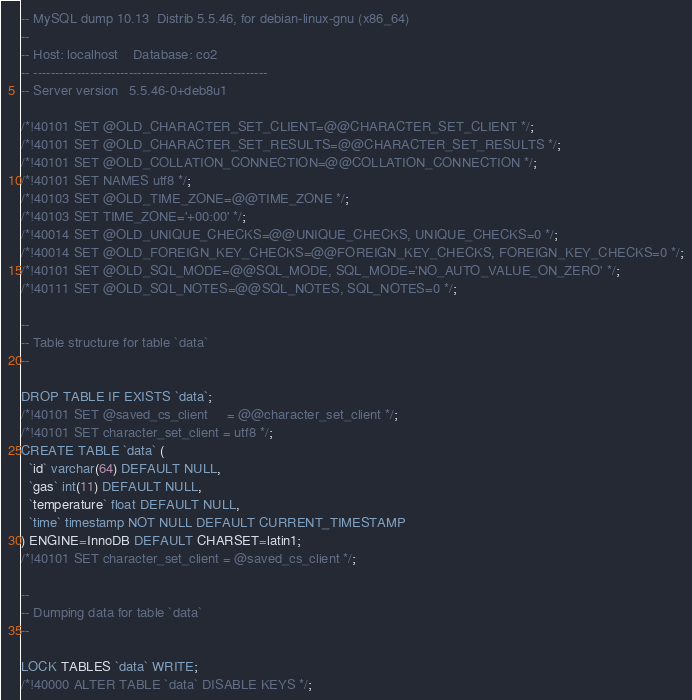Convert code to text. <code><loc_0><loc_0><loc_500><loc_500><_SQL_>-- MySQL dump 10.13  Distrib 5.5.46, for debian-linux-gnu (x86_64)
--
-- Host: localhost    Database: co2
-- ------------------------------------------------------
-- Server version	5.5.46-0+deb8u1

/*!40101 SET @OLD_CHARACTER_SET_CLIENT=@@CHARACTER_SET_CLIENT */;
/*!40101 SET @OLD_CHARACTER_SET_RESULTS=@@CHARACTER_SET_RESULTS */;
/*!40101 SET @OLD_COLLATION_CONNECTION=@@COLLATION_CONNECTION */;
/*!40101 SET NAMES utf8 */;
/*!40103 SET @OLD_TIME_ZONE=@@TIME_ZONE */;
/*!40103 SET TIME_ZONE='+00:00' */;
/*!40014 SET @OLD_UNIQUE_CHECKS=@@UNIQUE_CHECKS, UNIQUE_CHECKS=0 */;
/*!40014 SET @OLD_FOREIGN_KEY_CHECKS=@@FOREIGN_KEY_CHECKS, FOREIGN_KEY_CHECKS=0 */;
/*!40101 SET @OLD_SQL_MODE=@@SQL_MODE, SQL_MODE='NO_AUTO_VALUE_ON_ZERO' */;
/*!40111 SET @OLD_SQL_NOTES=@@SQL_NOTES, SQL_NOTES=0 */;

--
-- Table structure for table `data`
--

DROP TABLE IF EXISTS `data`;
/*!40101 SET @saved_cs_client     = @@character_set_client */;
/*!40101 SET character_set_client = utf8 */;
CREATE TABLE `data` (
  `id` varchar(64) DEFAULT NULL,
  `gas` int(11) DEFAULT NULL,
  `temperature` float DEFAULT NULL,
  `time` timestamp NOT NULL DEFAULT CURRENT_TIMESTAMP
) ENGINE=InnoDB DEFAULT CHARSET=latin1;
/*!40101 SET character_set_client = @saved_cs_client */;

--
-- Dumping data for table `data`
--

LOCK TABLES `data` WRITE;
/*!40000 ALTER TABLE `data` DISABLE KEYS */;</code> 